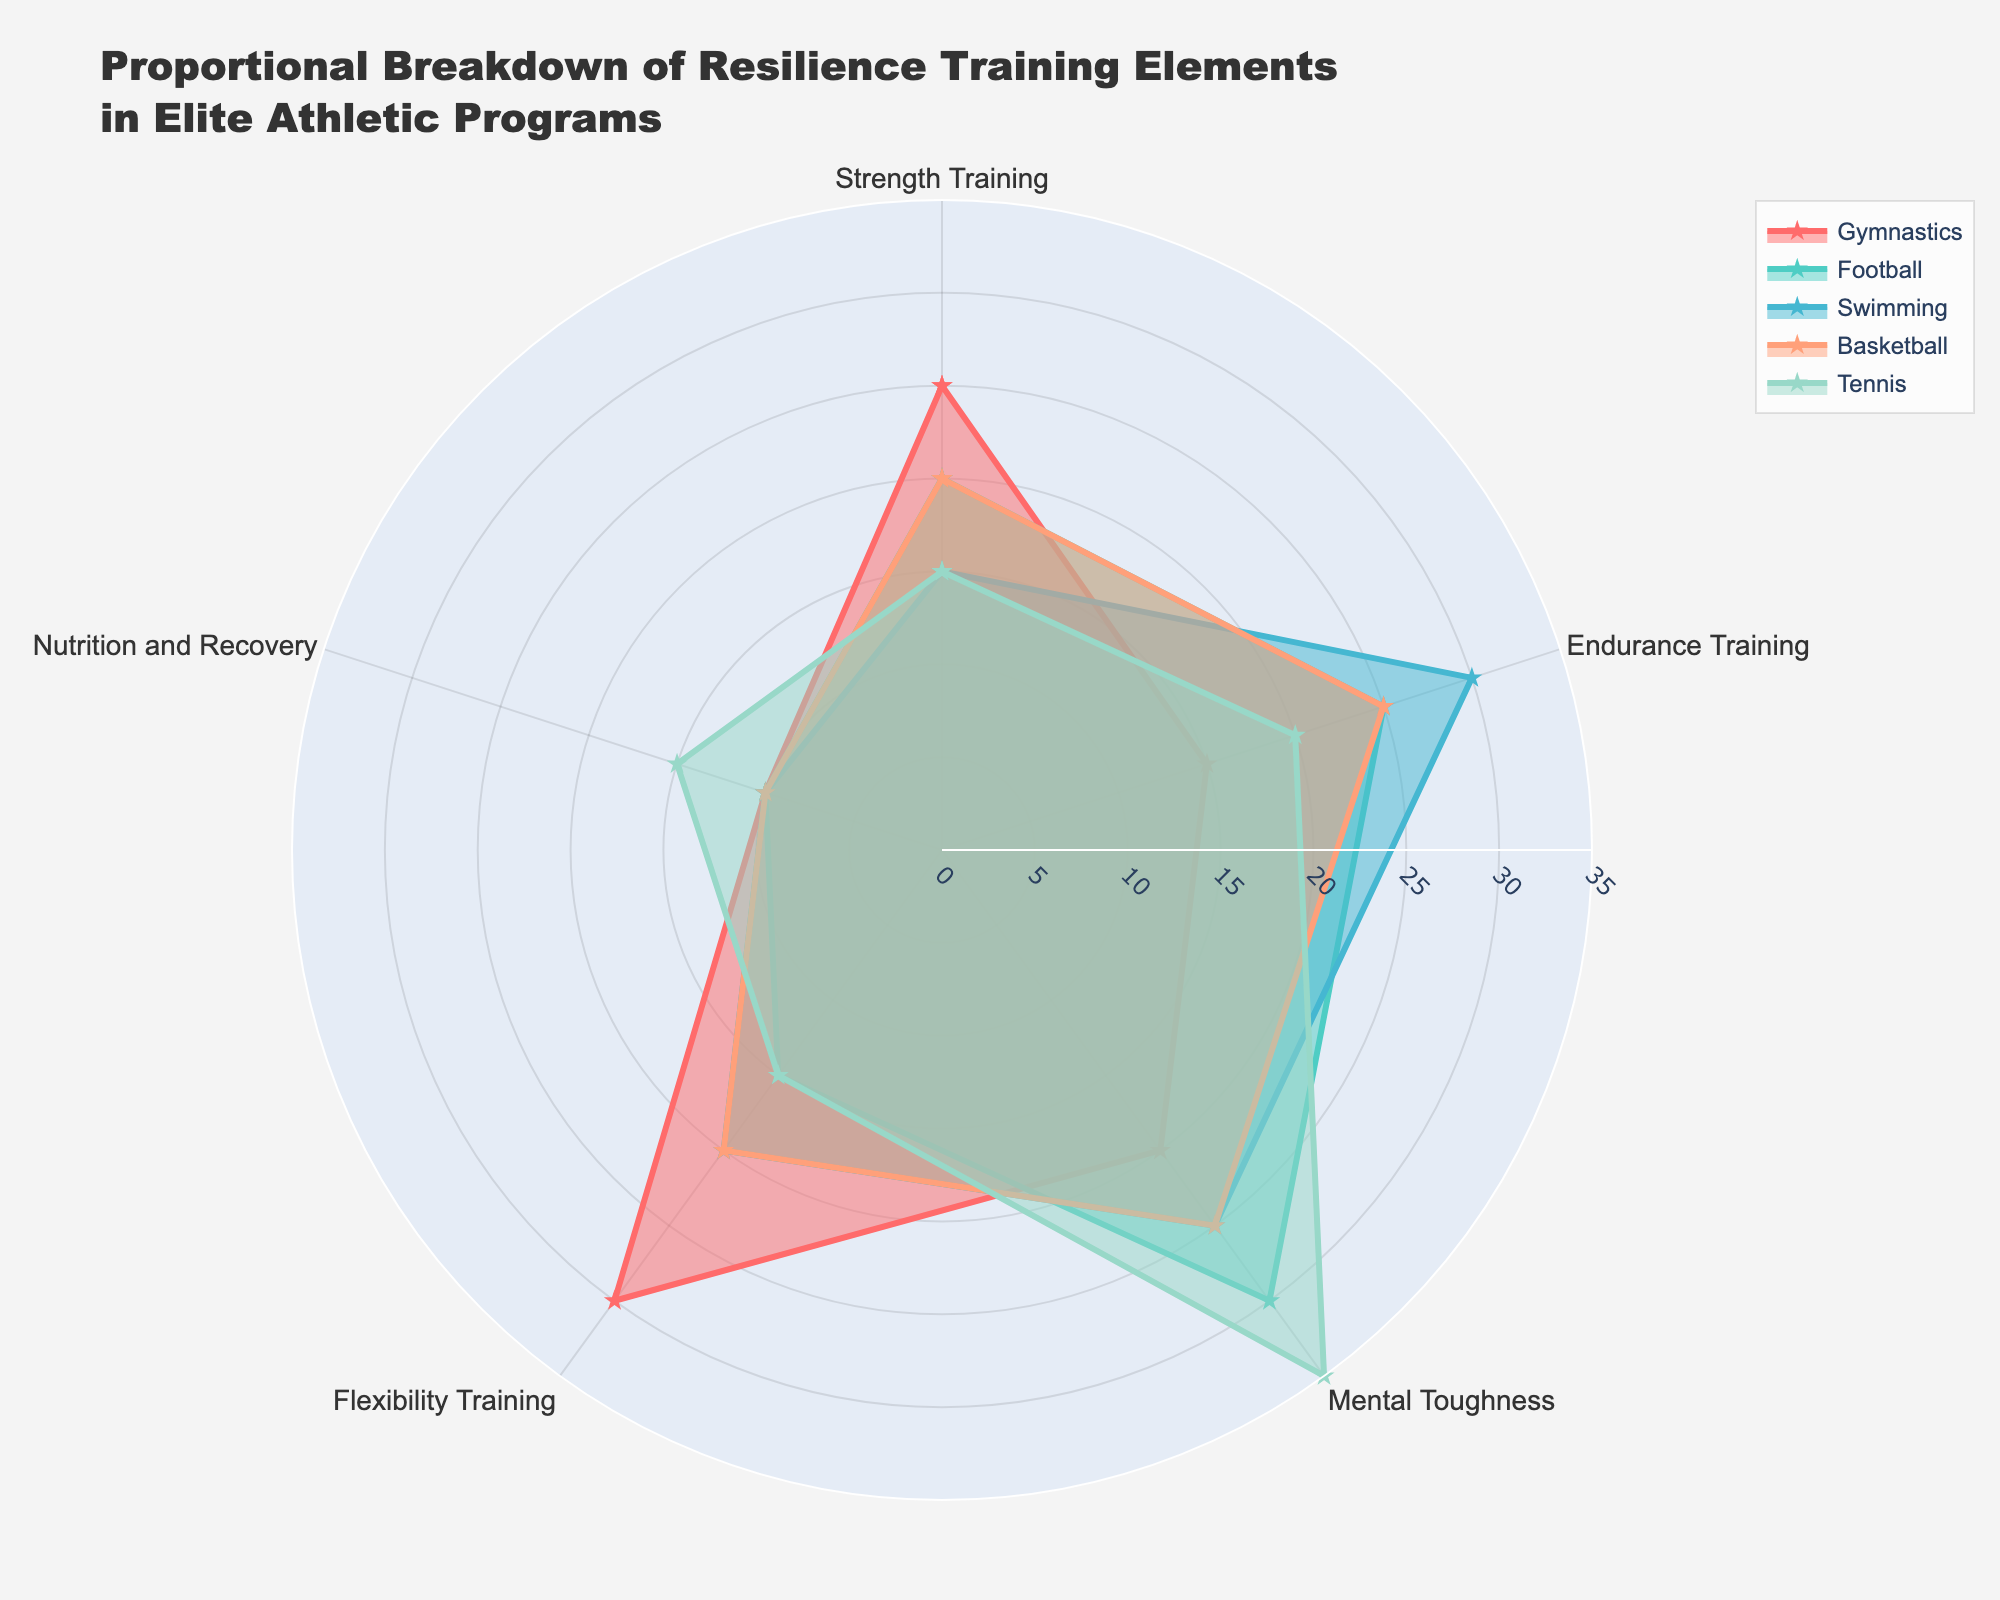What sport places the highest emphasis on Mental Toughness? According to the chart, Tennis has the highest value for Mental Toughness. The filled area representing Tennis extends the furthest in the direction labeled "Mental Toughness," indicating its highest value.
Answer: Tennis Which sport has the largest portion dedicated to Strength Training? Gymnastics has the largest portion dedicated to Strength Training. The filled area for Gymnastics extends furthest in the direction labeled "Strength Training," representing the highest value.
Answer: Gymnastics What is the combined value of Strength Training and Flexibility Training for Gymnastics? The value for Strength Training in Gymnastics is 25 and for Flexibility Training is 30. Adding these two values gives us 25 + 30 = 55.
Answer: 55 Compare the emphasis on Endurance Training between Swimming and Football. Swimming places a higher emphasis on Endurance Training with a value of 30, whereas Football has a value of 25 for the same category. This is shown by the larger radial extent of Swimming in the direction labeled "Endurance Training."
Answer: Swimming In terms of Nutrition and Recovery, which two sports allocate the highest portion, and are these portions equal? Both Tennis and Basketball allocate the highest portion to Nutrition and Recovery, each with a value of 15. This is visualized by the similar extension of their filled areas in the direction labeled "Nutrition and Recovery."
Answer: Tennis and Basketball, Yes Which sport evenly distributes its training efforts across Mental Toughness, Endurance Training, and Flexibility Training? Basketball shows an even distribution with each of these elements having values of 25, 25, and 20 respectively, indicating a balanced approach.
Answer: Basketball What is the total portion dedicated to all five elements of resilience training for Football? The portions for Football are: Strength Training - 20, Endurance Training - 25, Mental Toughness - 30, Flexibility Training - 15, and Nutrition and Recovery - 10. Summing these values, we get 20 + 25 + 30 + 15 + 10 = 100.
Answer: 100 Describe the overall emphasis of resilience training elements for Swimming compared to Gymnastics. Swimming emphasizes Endurance Training (30) and Mental Toughness (25) the most, while Gymnastics focuses more on Flexibility Training (30) and Strength Training (25). This is apparent from the radial extent of each category per sport.
Answer: Endurance and Mental Toughness for Swimming; Flexibility and Strength for Gymnastics 